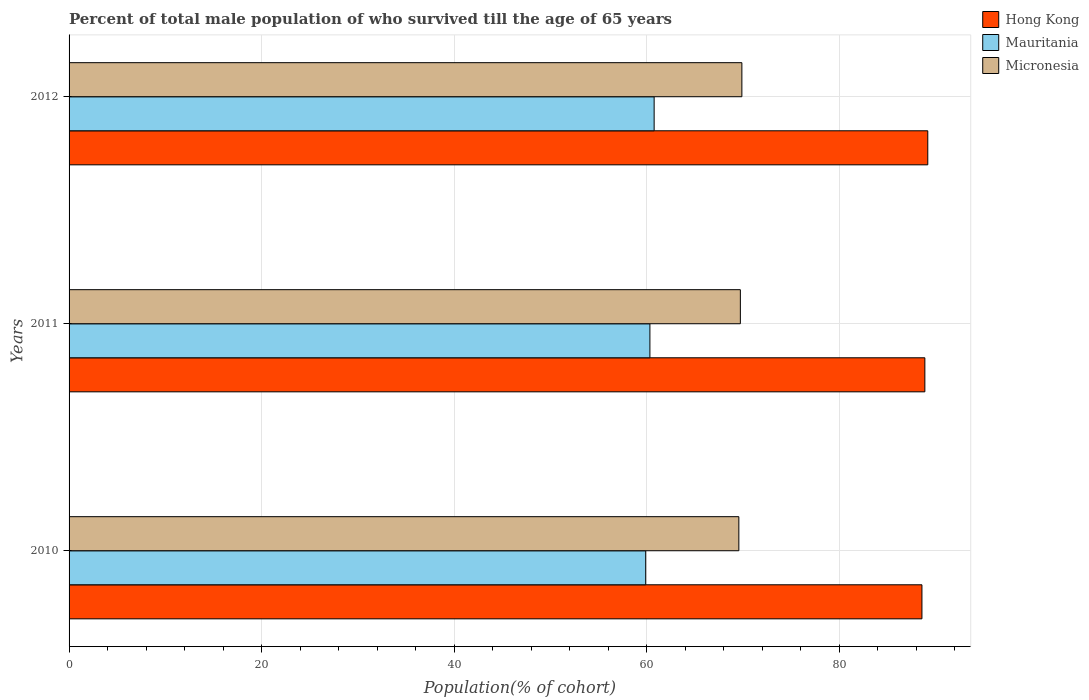How many groups of bars are there?
Provide a short and direct response. 3. Are the number of bars per tick equal to the number of legend labels?
Your answer should be compact. Yes. Are the number of bars on each tick of the Y-axis equal?
Your answer should be very brief. Yes. How many bars are there on the 2nd tick from the top?
Give a very brief answer. 3. What is the label of the 3rd group of bars from the top?
Keep it short and to the point. 2010. What is the percentage of total male population who survived till the age of 65 years in Mauritania in 2011?
Make the answer very short. 60.33. Across all years, what is the maximum percentage of total male population who survived till the age of 65 years in Hong Kong?
Ensure brevity in your answer.  89.2. Across all years, what is the minimum percentage of total male population who survived till the age of 65 years in Hong Kong?
Offer a terse response. 88.59. In which year was the percentage of total male population who survived till the age of 65 years in Hong Kong maximum?
Offer a terse response. 2012. In which year was the percentage of total male population who survived till the age of 65 years in Mauritania minimum?
Your answer should be very brief. 2010. What is the total percentage of total male population who survived till the age of 65 years in Hong Kong in the graph?
Ensure brevity in your answer.  266.68. What is the difference between the percentage of total male population who survived till the age of 65 years in Hong Kong in 2011 and that in 2012?
Your answer should be very brief. -0.3. What is the difference between the percentage of total male population who survived till the age of 65 years in Hong Kong in 2011 and the percentage of total male population who survived till the age of 65 years in Micronesia in 2012?
Your answer should be compact. 19.01. What is the average percentage of total male population who survived till the age of 65 years in Mauritania per year?
Your answer should be very brief. 60.33. In the year 2012, what is the difference between the percentage of total male population who survived till the age of 65 years in Micronesia and percentage of total male population who survived till the age of 65 years in Mauritania?
Give a very brief answer. 9.11. In how many years, is the percentage of total male population who survived till the age of 65 years in Hong Kong greater than 56 %?
Keep it short and to the point. 3. What is the ratio of the percentage of total male population who survived till the age of 65 years in Micronesia in 2010 to that in 2011?
Your answer should be compact. 1. What is the difference between the highest and the second highest percentage of total male population who survived till the age of 65 years in Mauritania?
Ensure brevity in your answer.  0.44. What is the difference between the highest and the lowest percentage of total male population who survived till the age of 65 years in Mauritania?
Your answer should be compact. 0.88. In how many years, is the percentage of total male population who survived till the age of 65 years in Hong Kong greater than the average percentage of total male population who survived till the age of 65 years in Hong Kong taken over all years?
Ensure brevity in your answer.  1. What does the 2nd bar from the top in 2011 represents?
Your response must be concise. Mauritania. What does the 2nd bar from the bottom in 2012 represents?
Offer a terse response. Mauritania. Does the graph contain any zero values?
Your response must be concise. No. Where does the legend appear in the graph?
Offer a terse response. Top right. What is the title of the graph?
Offer a very short reply. Percent of total male population of who survived till the age of 65 years. What is the label or title of the X-axis?
Make the answer very short. Population(% of cohort). What is the Population(% of cohort) of Hong Kong in 2010?
Your response must be concise. 88.59. What is the Population(% of cohort) of Mauritania in 2010?
Give a very brief answer. 59.9. What is the Population(% of cohort) in Micronesia in 2010?
Offer a terse response. 69.57. What is the Population(% of cohort) in Hong Kong in 2011?
Provide a short and direct response. 88.89. What is the Population(% of cohort) in Mauritania in 2011?
Offer a very short reply. 60.33. What is the Population(% of cohort) in Micronesia in 2011?
Your answer should be very brief. 69.73. What is the Population(% of cohort) in Hong Kong in 2012?
Your answer should be compact. 89.2. What is the Population(% of cohort) of Mauritania in 2012?
Keep it short and to the point. 60.77. What is the Population(% of cohort) of Micronesia in 2012?
Ensure brevity in your answer.  69.89. Across all years, what is the maximum Population(% of cohort) in Hong Kong?
Your answer should be very brief. 89.2. Across all years, what is the maximum Population(% of cohort) in Mauritania?
Ensure brevity in your answer.  60.77. Across all years, what is the maximum Population(% of cohort) of Micronesia?
Make the answer very short. 69.89. Across all years, what is the minimum Population(% of cohort) in Hong Kong?
Your response must be concise. 88.59. Across all years, what is the minimum Population(% of cohort) of Mauritania?
Your answer should be very brief. 59.9. Across all years, what is the minimum Population(% of cohort) in Micronesia?
Your answer should be very brief. 69.57. What is the total Population(% of cohort) in Hong Kong in the graph?
Your answer should be compact. 266.68. What is the total Population(% of cohort) in Mauritania in the graph?
Keep it short and to the point. 181. What is the total Population(% of cohort) of Micronesia in the graph?
Your response must be concise. 209.19. What is the difference between the Population(% of cohort) in Hong Kong in 2010 and that in 2011?
Give a very brief answer. -0.3. What is the difference between the Population(% of cohort) in Mauritania in 2010 and that in 2011?
Provide a short and direct response. -0.44. What is the difference between the Population(% of cohort) of Micronesia in 2010 and that in 2011?
Provide a short and direct response. -0.16. What is the difference between the Population(% of cohort) in Hong Kong in 2010 and that in 2012?
Your answer should be very brief. -0.61. What is the difference between the Population(% of cohort) of Mauritania in 2010 and that in 2012?
Provide a short and direct response. -0.88. What is the difference between the Population(% of cohort) in Micronesia in 2010 and that in 2012?
Offer a very short reply. -0.32. What is the difference between the Population(% of cohort) in Hong Kong in 2011 and that in 2012?
Offer a terse response. -0.3. What is the difference between the Population(% of cohort) in Mauritania in 2011 and that in 2012?
Provide a short and direct response. -0.44. What is the difference between the Population(% of cohort) of Micronesia in 2011 and that in 2012?
Provide a short and direct response. -0.16. What is the difference between the Population(% of cohort) of Hong Kong in 2010 and the Population(% of cohort) of Mauritania in 2011?
Ensure brevity in your answer.  28.26. What is the difference between the Population(% of cohort) of Hong Kong in 2010 and the Population(% of cohort) of Micronesia in 2011?
Your answer should be very brief. 18.86. What is the difference between the Population(% of cohort) of Mauritania in 2010 and the Population(% of cohort) of Micronesia in 2011?
Provide a short and direct response. -9.83. What is the difference between the Population(% of cohort) of Hong Kong in 2010 and the Population(% of cohort) of Mauritania in 2012?
Ensure brevity in your answer.  27.82. What is the difference between the Population(% of cohort) in Hong Kong in 2010 and the Population(% of cohort) in Micronesia in 2012?
Provide a short and direct response. 18.7. What is the difference between the Population(% of cohort) of Mauritania in 2010 and the Population(% of cohort) of Micronesia in 2012?
Provide a short and direct response. -9.99. What is the difference between the Population(% of cohort) in Hong Kong in 2011 and the Population(% of cohort) in Mauritania in 2012?
Your answer should be compact. 28.12. What is the difference between the Population(% of cohort) of Hong Kong in 2011 and the Population(% of cohort) of Micronesia in 2012?
Keep it short and to the point. 19.01. What is the difference between the Population(% of cohort) of Mauritania in 2011 and the Population(% of cohort) of Micronesia in 2012?
Ensure brevity in your answer.  -9.55. What is the average Population(% of cohort) of Hong Kong per year?
Provide a succinct answer. 88.89. What is the average Population(% of cohort) of Mauritania per year?
Your answer should be compact. 60.33. What is the average Population(% of cohort) in Micronesia per year?
Offer a terse response. 69.73. In the year 2010, what is the difference between the Population(% of cohort) of Hong Kong and Population(% of cohort) of Mauritania?
Make the answer very short. 28.7. In the year 2010, what is the difference between the Population(% of cohort) of Hong Kong and Population(% of cohort) of Micronesia?
Keep it short and to the point. 19.02. In the year 2010, what is the difference between the Population(% of cohort) of Mauritania and Population(% of cohort) of Micronesia?
Your response must be concise. -9.68. In the year 2011, what is the difference between the Population(% of cohort) of Hong Kong and Population(% of cohort) of Mauritania?
Your answer should be very brief. 28.56. In the year 2011, what is the difference between the Population(% of cohort) in Hong Kong and Population(% of cohort) in Micronesia?
Provide a short and direct response. 19.16. In the year 2011, what is the difference between the Population(% of cohort) of Mauritania and Population(% of cohort) of Micronesia?
Provide a short and direct response. -9.4. In the year 2012, what is the difference between the Population(% of cohort) in Hong Kong and Population(% of cohort) in Mauritania?
Make the answer very short. 28.42. In the year 2012, what is the difference between the Population(% of cohort) of Hong Kong and Population(% of cohort) of Micronesia?
Provide a succinct answer. 19.31. In the year 2012, what is the difference between the Population(% of cohort) of Mauritania and Population(% of cohort) of Micronesia?
Offer a terse response. -9.11. What is the ratio of the Population(% of cohort) in Hong Kong in 2010 to that in 2011?
Offer a terse response. 1. What is the ratio of the Population(% of cohort) of Mauritania in 2010 to that in 2011?
Provide a short and direct response. 0.99. What is the ratio of the Population(% of cohort) in Mauritania in 2010 to that in 2012?
Give a very brief answer. 0.99. What is the ratio of the Population(% of cohort) in Micronesia in 2010 to that in 2012?
Your answer should be very brief. 1. What is the ratio of the Population(% of cohort) of Hong Kong in 2011 to that in 2012?
Keep it short and to the point. 1. What is the ratio of the Population(% of cohort) in Micronesia in 2011 to that in 2012?
Keep it short and to the point. 1. What is the difference between the highest and the second highest Population(% of cohort) in Hong Kong?
Give a very brief answer. 0.3. What is the difference between the highest and the second highest Population(% of cohort) in Mauritania?
Your answer should be very brief. 0.44. What is the difference between the highest and the second highest Population(% of cohort) in Micronesia?
Your response must be concise. 0.16. What is the difference between the highest and the lowest Population(% of cohort) of Hong Kong?
Keep it short and to the point. 0.61. What is the difference between the highest and the lowest Population(% of cohort) of Mauritania?
Offer a very short reply. 0.88. What is the difference between the highest and the lowest Population(% of cohort) in Micronesia?
Your answer should be compact. 0.32. 